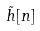Convert formula to latex. <formula><loc_0><loc_0><loc_500><loc_500>\tilde { h } [ n ]</formula> 